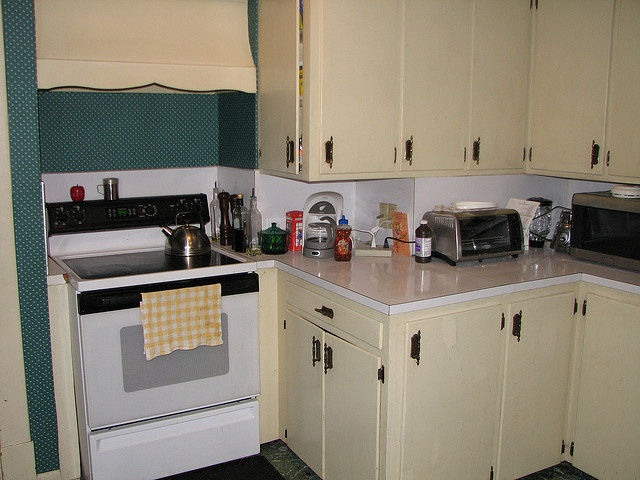Describe the objects in this image and their specific colors. I can see oven in gray, darkgray, black, and tan tones, microwave in gray and black tones, toaster in gray and black tones, bottle in gray, black, and darkgreen tones, and bottle in gray and black tones in this image. 